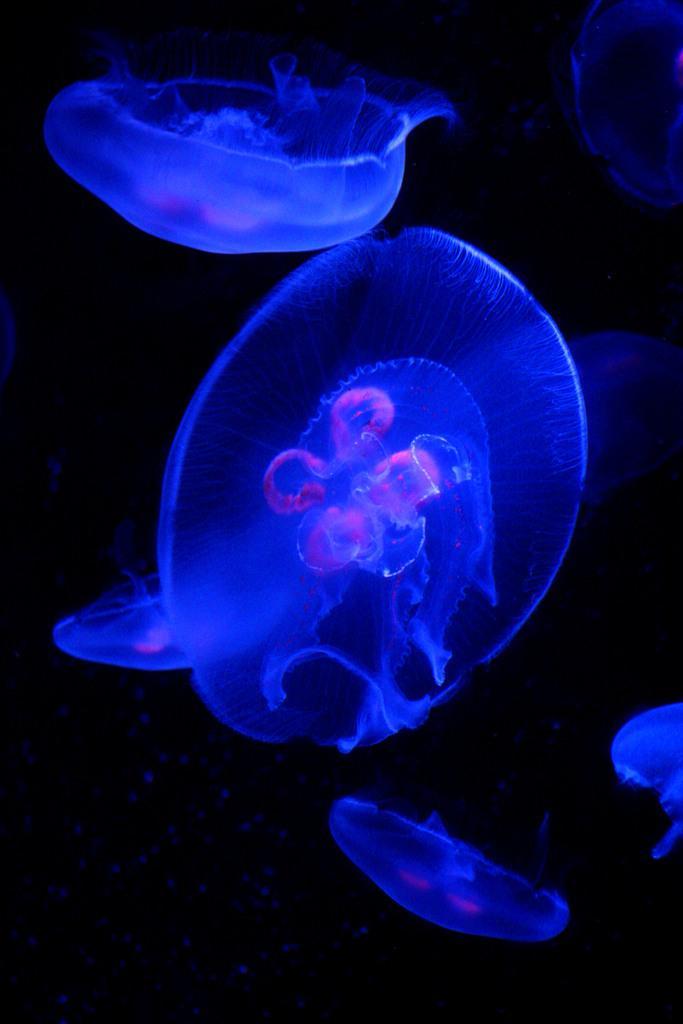Could you give a brief overview of what you see in this image? In this image, we can see there are jellyfish in the water. And the background is dark in color. 